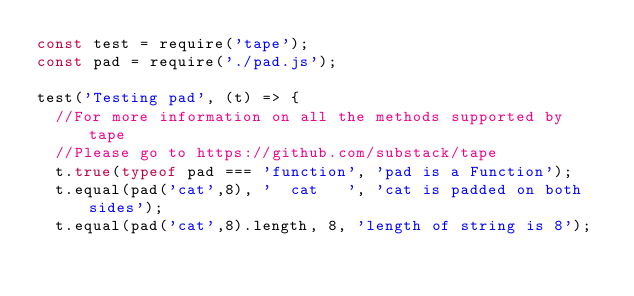Convert code to text. <code><loc_0><loc_0><loc_500><loc_500><_JavaScript_>const test = require('tape');
const pad = require('./pad.js');

test('Testing pad', (t) => {
  //For more information on all the methods supported by tape
  //Please go to https://github.com/substack/tape
  t.true(typeof pad === 'function', 'pad is a Function');
  t.equal(pad('cat',8), '  cat   ', 'cat is padded on both sides');
  t.equal(pad('cat',8).length, 8, 'length of string is 8');</code> 